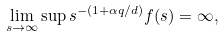<formula> <loc_0><loc_0><loc_500><loc_500>\lim _ { s \rightarrow \infty } \sup s ^ { - ( 1 + \alpha q / d ) } f ( s ) = \infty ,</formula> 